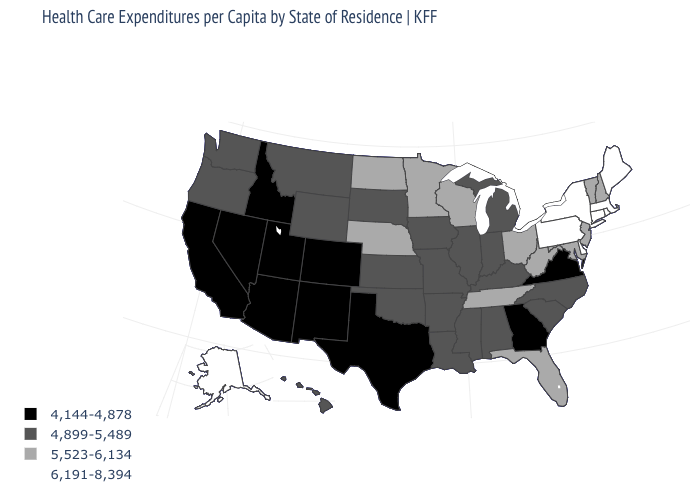What is the value of Utah?
Quick response, please. 4,144-4,878. How many symbols are there in the legend?
Write a very short answer. 4. Among the states that border Kansas , which have the highest value?
Be succinct. Nebraska. Does the map have missing data?
Keep it brief. No. What is the value of Tennessee?
Be succinct. 5,523-6,134. Name the states that have a value in the range 4,144-4,878?
Answer briefly. Arizona, California, Colorado, Georgia, Idaho, Nevada, New Mexico, Texas, Utah, Virginia. Among the states that border New Jersey , which have the highest value?
Concise answer only. Delaware, New York, Pennsylvania. Name the states that have a value in the range 6,191-8,394?
Quick response, please. Alaska, Connecticut, Delaware, Maine, Massachusetts, New York, Pennsylvania, Rhode Island. Does the first symbol in the legend represent the smallest category?
Concise answer only. Yes. Does the first symbol in the legend represent the smallest category?
Concise answer only. Yes. Name the states that have a value in the range 6,191-8,394?
Keep it brief. Alaska, Connecticut, Delaware, Maine, Massachusetts, New York, Pennsylvania, Rhode Island. Which states have the lowest value in the USA?
Give a very brief answer. Arizona, California, Colorado, Georgia, Idaho, Nevada, New Mexico, Texas, Utah, Virginia. Which states have the highest value in the USA?
Write a very short answer. Alaska, Connecticut, Delaware, Maine, Massachusetts, New York, Pennsylvania, Rhode Island. Among the states that border Illinois , does Kentucky have the highest value?
Answer briefly. No. 